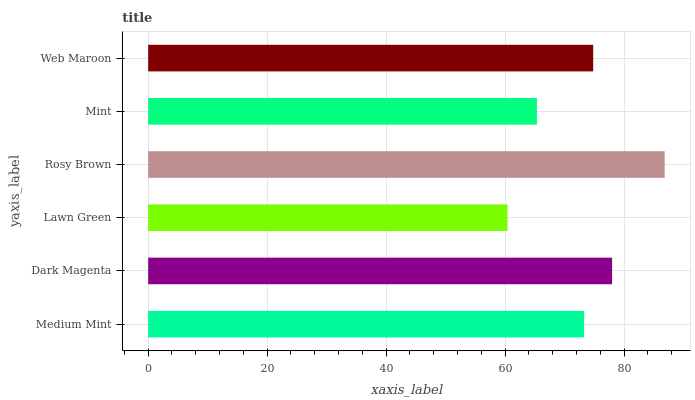Is Lawn Green the minimum?
Answer yes or no. Yes. Is Rosy Brown the maximum?
Answer yes or no. Yes. Is Dark Magenta the minimum?
Answer yes or no. No. Is Dark Magenta the maximum?
Answer yes or no. No. Is Dark Magenta greater than Medium Mint?
Answer yes or no. Yes. Is Medium Mint less than Dark Magenta?
Answer yes or no. Yes. Is Medium Mint greater than Dark Magenta?
Answer yes or no. No. Is Dark Magenta less than Medium Mint?
Answer yes or no. No. Is Web Maroon the high median?
Answer yes or no. Yes. Is Medium Mint the low median?
Answer yes or no. Yes. Is Mint the high median?
Answer yes or no. No. Is Mint the low median?
Answer yes or no. No. 